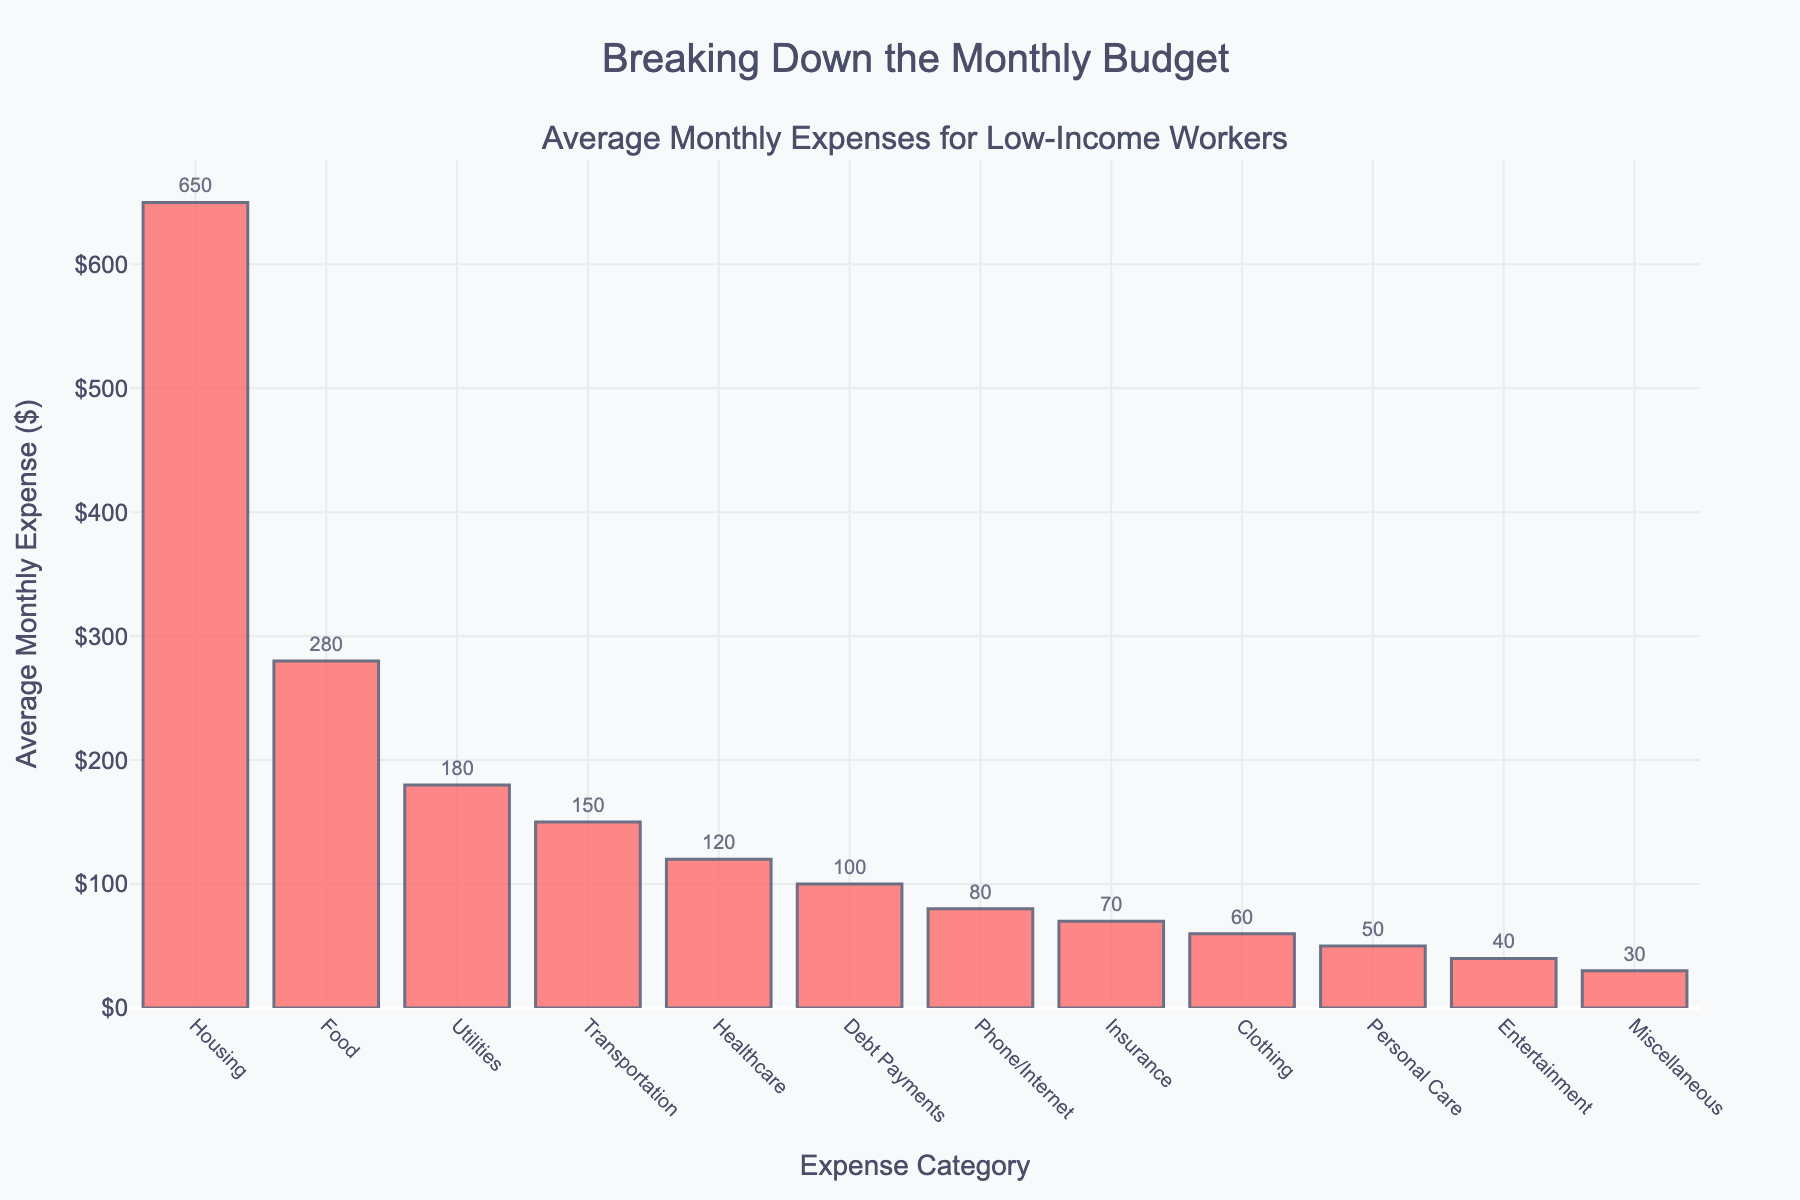Which category has the highest average monthly expense? The category with the highest bar represents the one with the highest expense. By observing the lengths, Housing has the longest bar.
Answer: Housing Which category has the lowest average monthly expense? The category with the shortest bar represents the one with the lowest expense. By observing the lengths, Miscellaneous has the shortest bar.
Answer: Miscellaneous What is the total average monthly expense for Housing, Food, and Transportation combined? Sum up the expenses for Housing ($650), Food ($280), and Transportation ($150). 650 + 280 + 150 = 1080.
Answer: 1080 How much more is spent on Housing compared to Utilities? Subtract the Utilities expense from the Housing expense. 650 (Housing) - 180 (Utilities) = 470.
Answer: 470 Which categories have an average monthly expense of less than $100? Identify the categories with bars shorter than the $100 line. These categories are Phone/Internet ($80), Personal Care ($50), Clothing ($60), Entertainment ($40), Insurance ($70), and Miscellaneous ($30).
Answer: Phone/Internet, Personal Care, Clothing, Entertainment, Insurance, Miscellaneous What is the difference in average monthly expense between Debt Payments and Insurance? Subtract the Insurance expense from the Debt Payments expense. 100 (Debt Payments) - 70 (Insurance) = 30.
Answer: 30 Which category has a higher average monthly expense: Transportation or Healthcare? Compare the heights of the bars for Transportation ($150) and Healthcare ($120). Transportation has the higher bar.
Answer: Transportation What is the combined average monthly expense for Entertainment, Debt Payments, and Clothing? Add together the expenses for Entertainment ($40), Debt Payments ($100), and Clothing ($60). 40 + 100 + 60 = 200.
Answer: 200 Which two categories have the closest average monthly expenses? Find pairs of bars with similar lengths. Healthcare ($120) and Debt Payments ($100) are closest.
Answer: Healthcare, Debt Payments By how much does the expense for Food exceed that for Phone/Internet? Subtract the Phone/Internet expense from the Food expense. 280 (Food) - 80 (Phone/Internet) = 200.
Answer: 200 